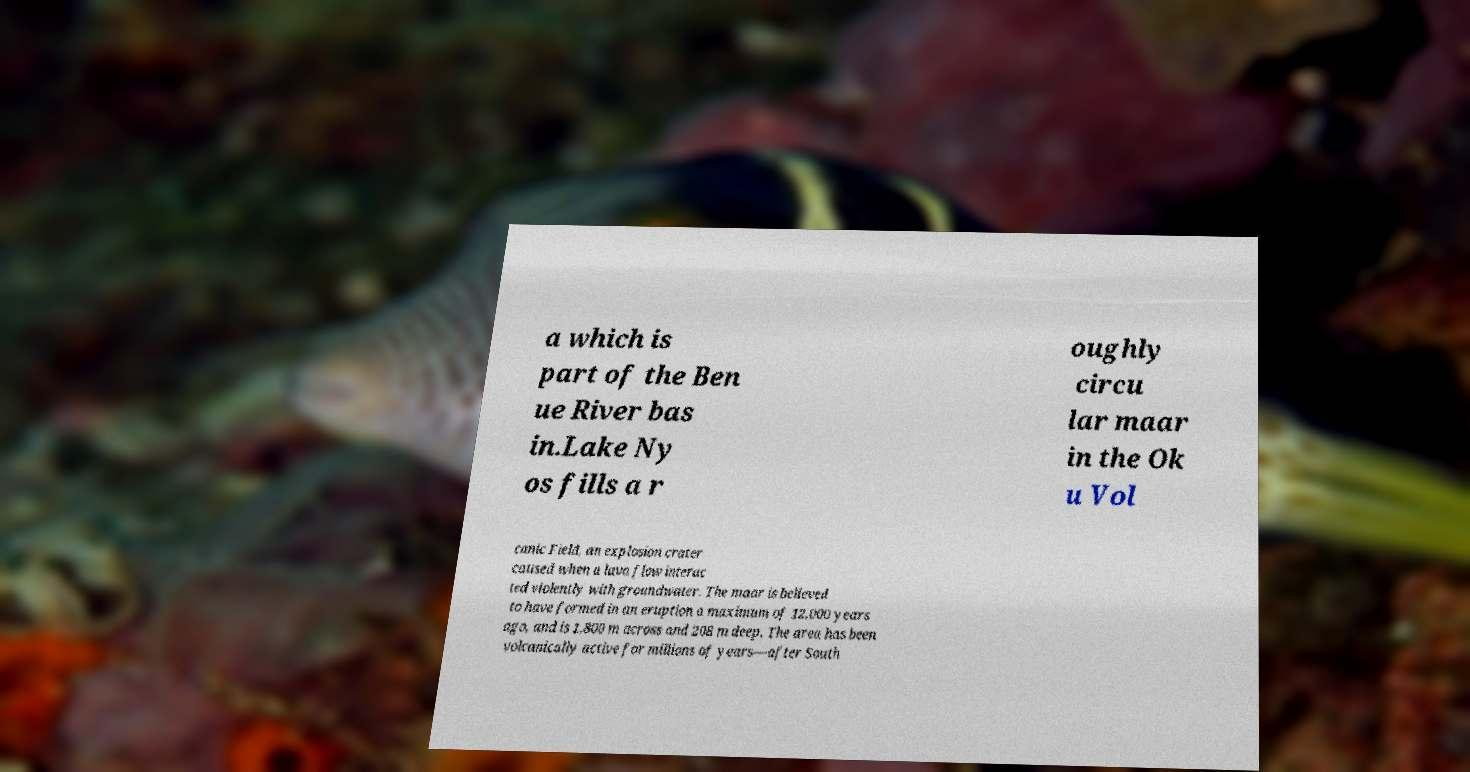For documentation purposes, I need the text within this image transcribed. Could you provide that? a which is part of the Ben ue River bas in.Lake Ny os fills a r oughly circu lar maar in the Ok u Vol canic Field, an explosion crater caused when a lava flow interac ted violently with groundwater. The maar is believed to have formed in an eruption a maximum of 12,000 years ago, and is 1,800 m across and 208 m deep. The area has been volcanically active for millions of years—after South 